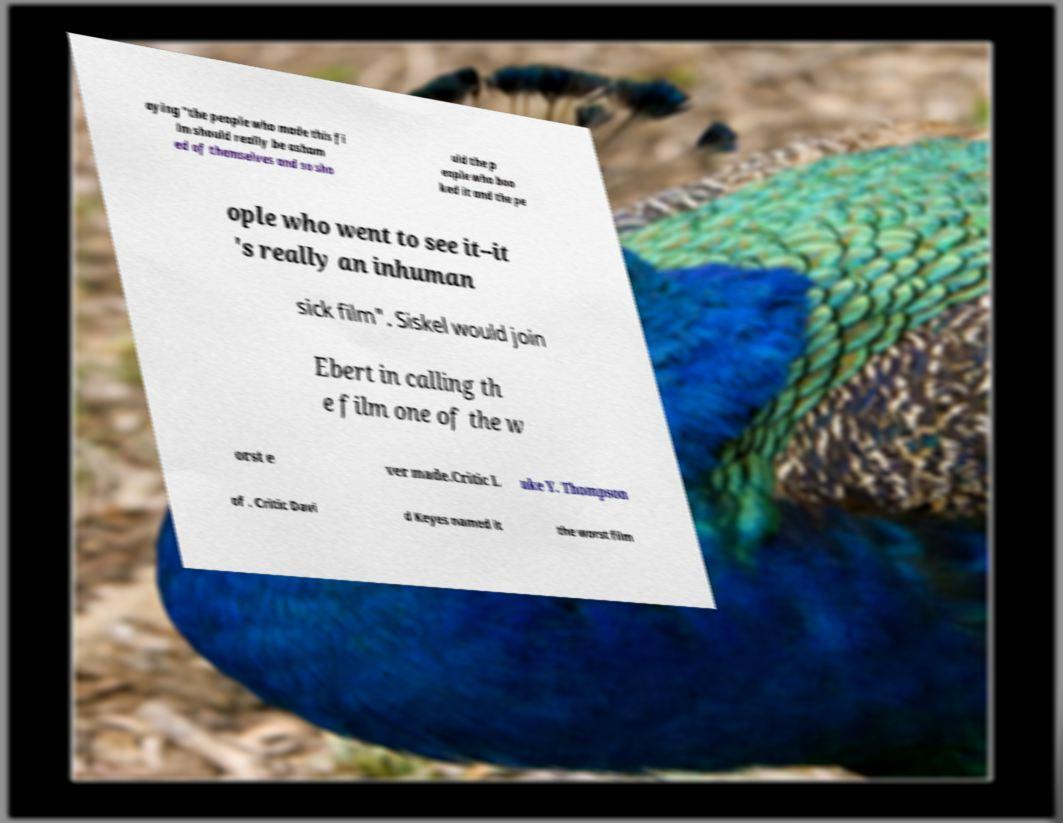Could you assist in decoding the text presented in this image and type it out clearly? aying "the people who made this fi lm should really be asham ed of themselves and so sho uld the p eople who boo ked it and the pe ople who went to see it--it 's really an inhuman sick film". Siskel would join Ebert in calling th e film one of the w orst e ver made.Critic L uke Y. Thompson of . Critic Davi d Keyes named it the worst film 